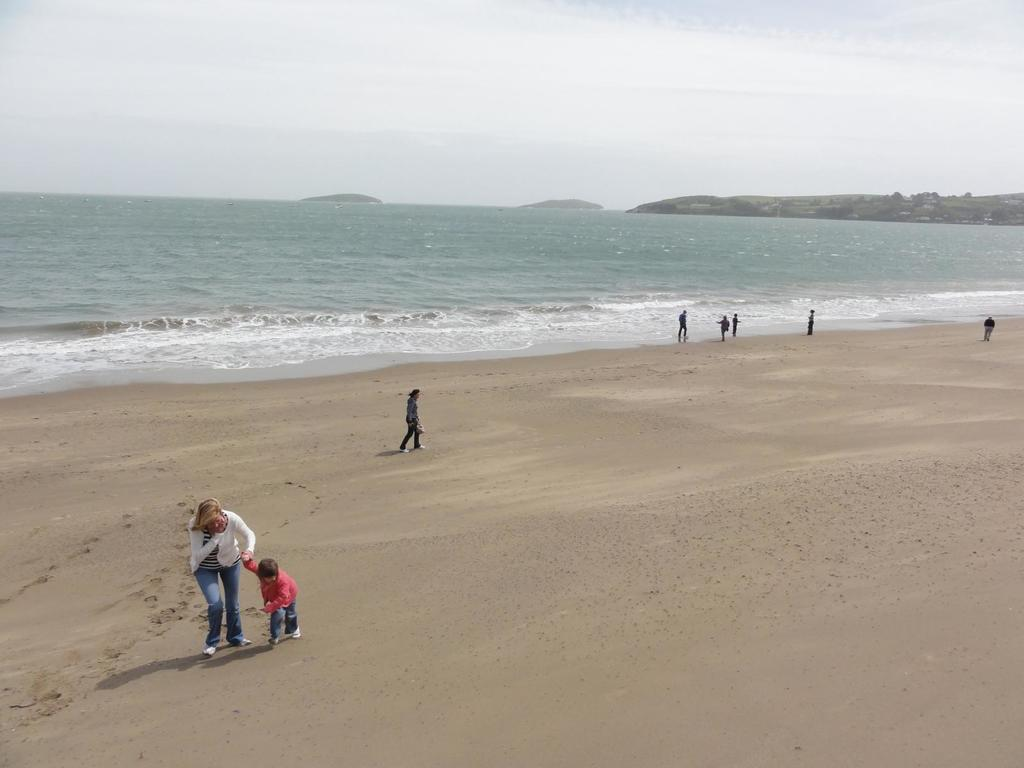What type of location is depicted in the image? There is a beach in the image. What is the terrain of the beach? The beach has sand. What are the people on the beach doing? The people are walking and standing on the beach. How close are the people to the water? The people are near the water. What can be seen in the distance behind the beach? There are hills visible in the background of the image. What is visible above the beach and hills? The sky is visible in the background of the image. Can you tell me how many boats are in the harbor in the image? There is no harbor present in the image; it features a beach with people near the water. What type of steam is coming from the people on the beach? There is no steam visible in the image; the people are simply walking and standing on the beach. 